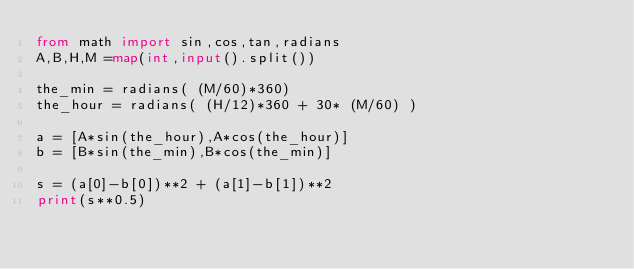Convert code to text. <code><loc_0><loc_0><loc_500><loc_500><_Python_>from math import sin,cos,tan,radians
A,B,H,M =map(int,input().split())

the_min = radians( (M/60)*360)
the_hour = radians( (H/12)*360 + 30* (M/60) )

a = [A*sin(the_hour),A*cos(the_hour)]
b = [B*sin(the_min),B*cos(the_min)]

s = (a[0]-b[0])**2 + (a[1]-b[1])**2
print(s**0.5)</code> 